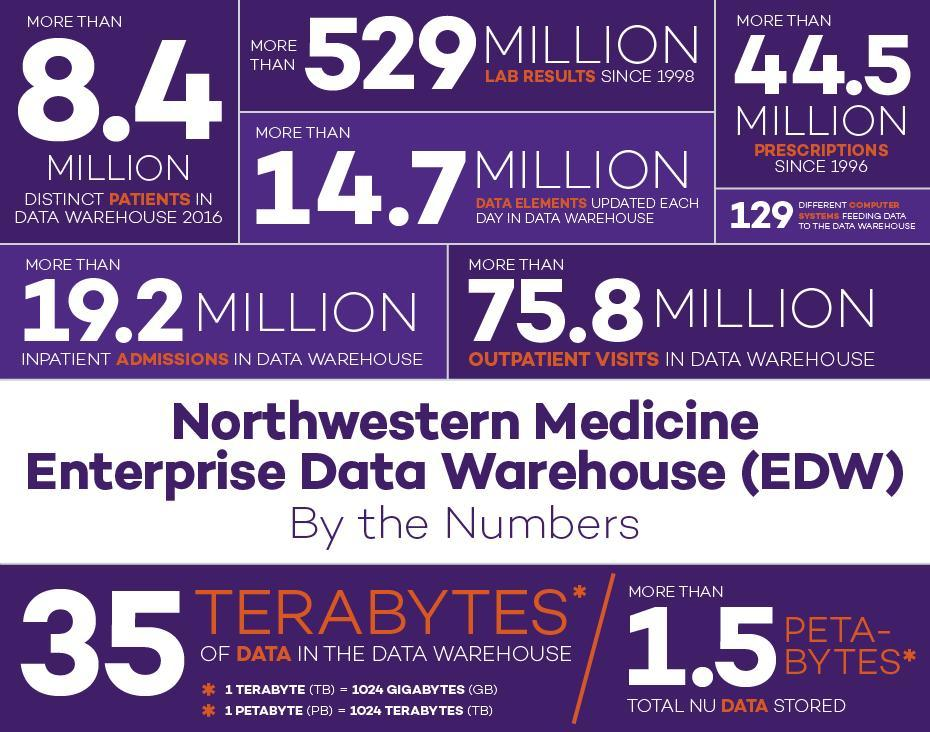What is the number of laboratory results in the data warehouse in millions, 8.8+, 529+, or 44.5+ ?
Answer the question with a short phrase. 529+ Compare the numbers of patients admitted and patients visiting the doctor. Give the higher number? 75.8 Million What is value of 35 Terabytes in Gigabytes? 35,840 Gigabytes (GB) 